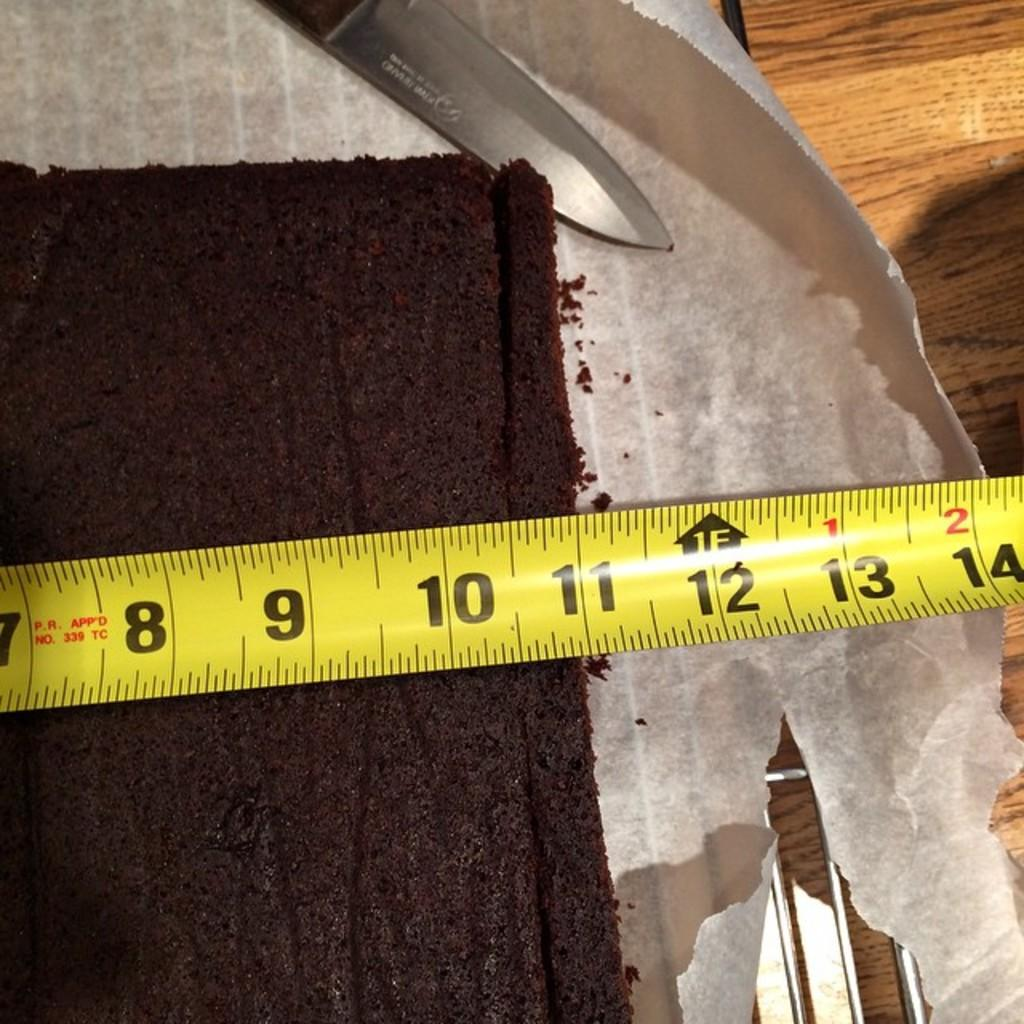<image>
Write a terse but informative summary of the picture. A tape measure showing a chocolate cake is 11" wide. 